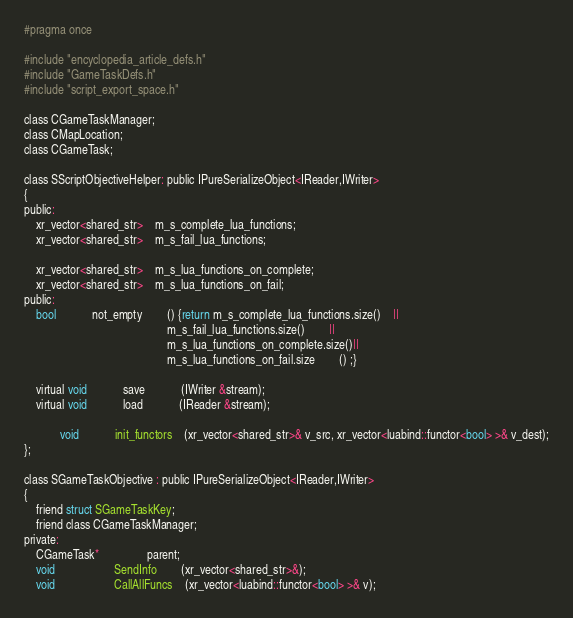Convert code to text. <code><loc_0><loc_0><loc_500><loc_500><_C_>#pragma once

#include "encyclopedia_article_defs.h"
#include "GameTaskDefs.h"
#include "script_export_space.h"

class CGameTaskManager;
class CMapLocation;
class CGameTask;

class SScriptObjectiveHelper: public IPureSerializeObject<IReader,IWriter>
{
public:
	xr_vector<shared_str>	m_s_complete_lua_functions;
	xr_vector<shared_str>	m_s_fail_lua_functions;

	xr_vector<shared_str>	m_s_lua_functions_on_complete;
	xr_vector<shared_str>	m_s_lua_functions_on_fail;
public:
	bool			not_empty		() {return m_s_complete_lua_functions.size()	||
												m_s_fail_lua_functions.size()		||
												m_s_lua_functions_on_complete.size()||
												m_s_lua_functions_on_fail.size		() ;}

	virtual void			save			(IWriter &stream);
	virtual void			load			(IReader &stream);
			
			void			init_functors	(xr_vector<shared_str>& v_src, xr_vector<luabind::functor<bool> >& v_dest);
};

class SGameTaskObjective : public IPureSerializeObject<IReader,IWriter>
{
	friend struct SGameTaskKey;
	friend class CGameTaskManager;
private:
	CGameTask*				parent;
	void					SendInfo		(xr_vector<shared_str>&);
	void					CallAllFuncs	(xr_vector<luabind::functor<bool> >& v);</code> 